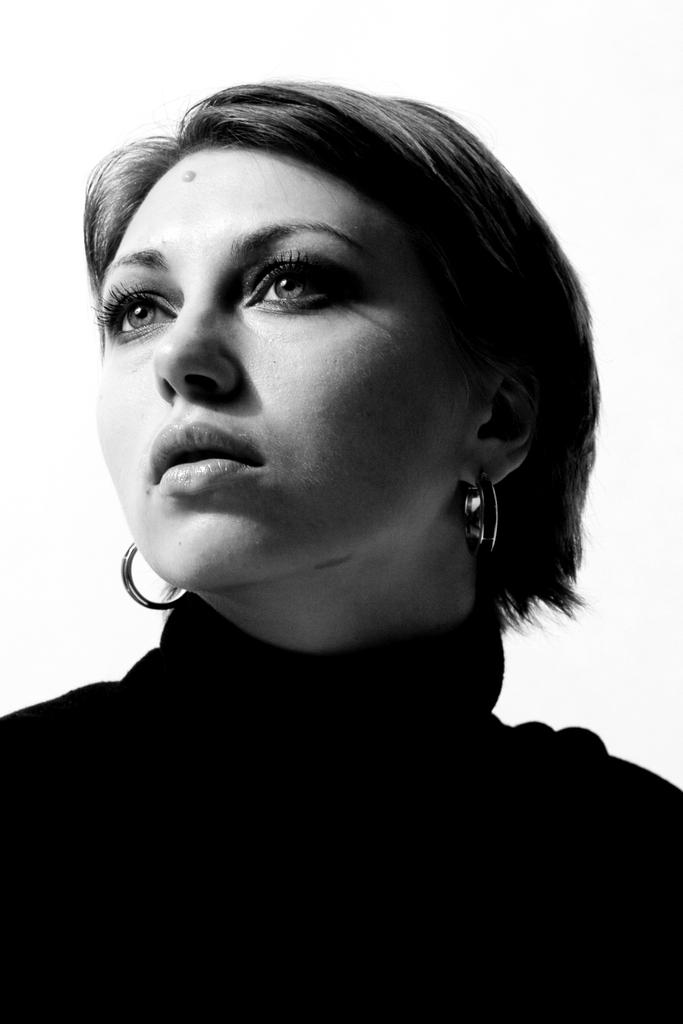Who is the main subject in the image? There is a woman in the image. What accessory is the woman wearing? The woman is wearing earrings. What is the color scheme of the image? The image is black and white in color. Who is the owner of the trick in the image? There is no trick present in the image, so it is not possible to determine the owner. 